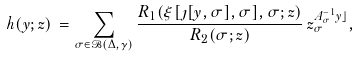<formula> <loc_0><loc_0><loc_500><loc_500>h ( y ; z ) \, = \sum _ { \sigma \in \mathcal { B } ( \Delta , \gamma ) } \frac { R _ { 1 } ( \xi [ \jmath [ y , \sigma ] , \sigma ] , \sigma ; z ) } { R _ { 2 } ( \sigma ; z ) } \, z _ { \sigma } ^ { A _ { \sigma } ^ { - 1 } y \rfloor } ,</formula> 